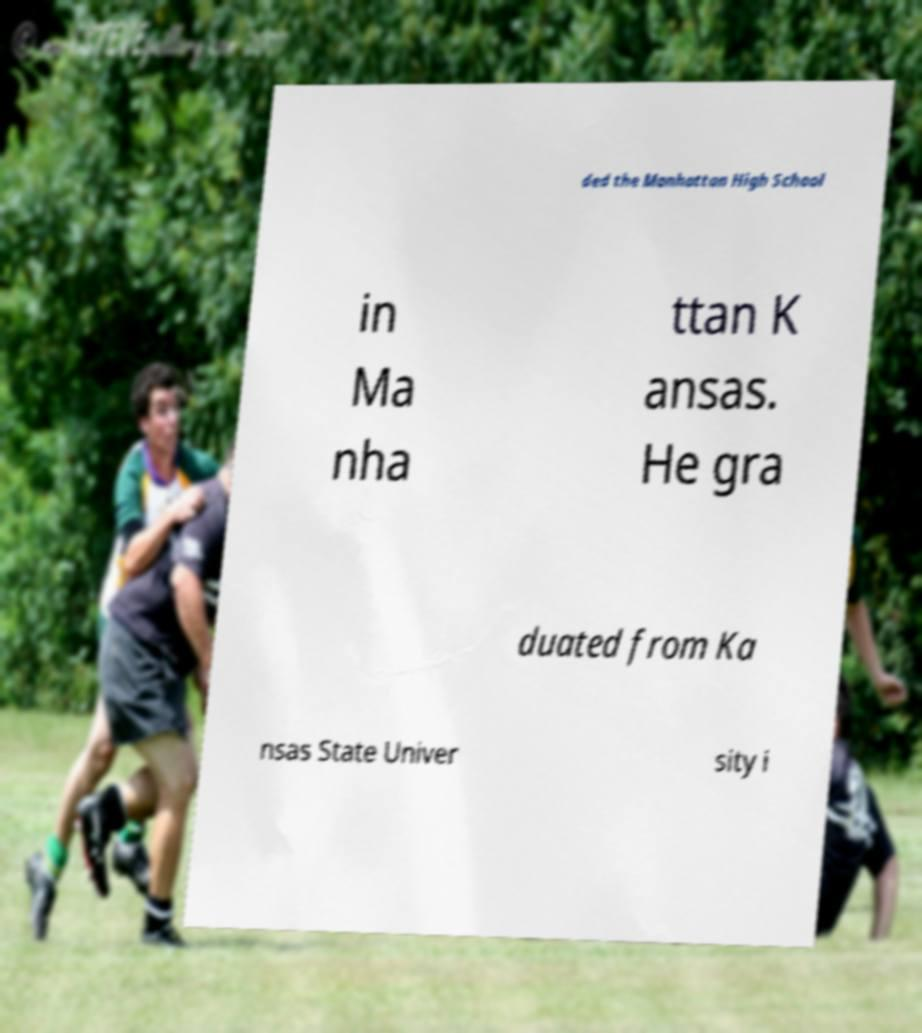Can you accurately transcribe the text from the provided image for me? ded the Manhattan High School in Ma nha ttan K ansas. He gra duated from Ka nsas State Univer sity i 